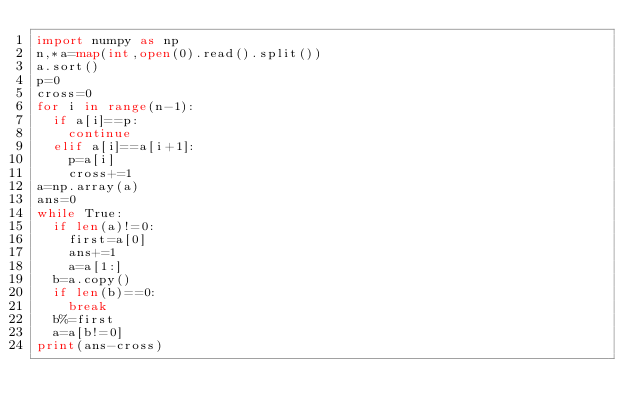<code> <loc_0><loc_0><loc_500><loc_500><_Python_>import numpy as np
n,*a=map(int,open(0).read().split())
a.sort()
p=0
cross=0
for i in range(n-1):
  if a[i]==p:
    continue
  elif a[i]==a[i+1]:
    p=a[i]
    cross+=1
a=np.array(a)
ans=0
while True:
  if len(a)!=0:
    first=a[0]
    ans+=1
    a=a[1:]
  b=a.copy()
  if len(b)==0:
    break
  b%=first
  a=a[b!=0]
print(ans-cross)</code> 